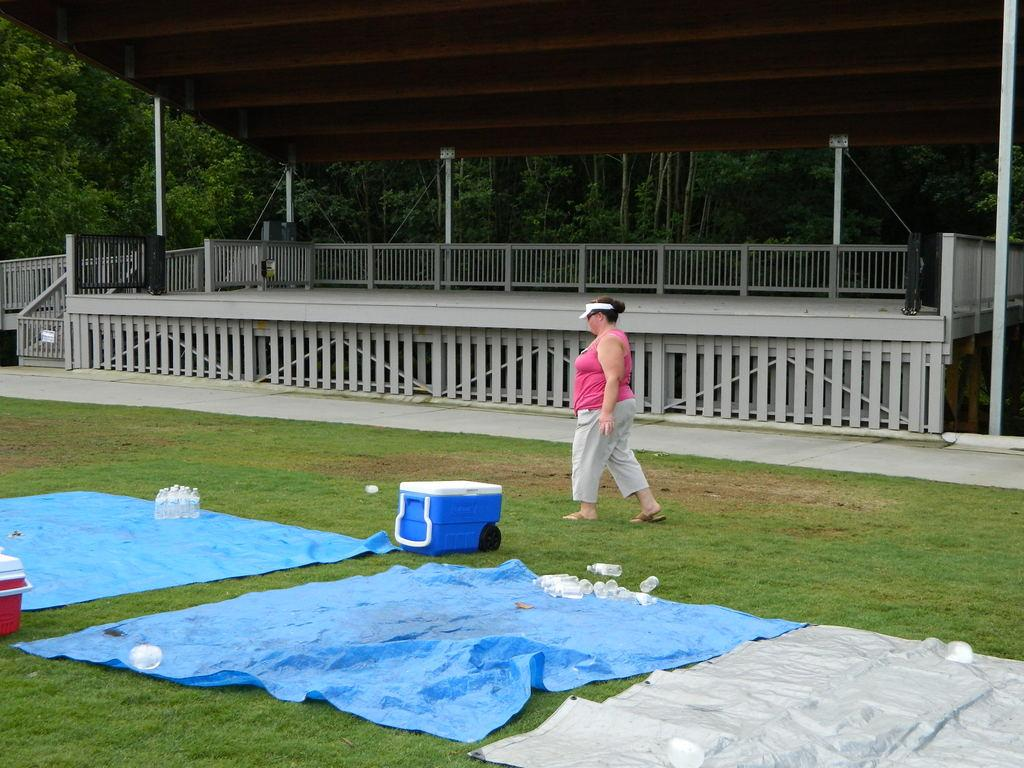What is the person in the image doing? The person is walking in the image. What color is the t-shirt the person is wearing? The person is wearing a pink t-shirt. What type of pants is the person wearing? The person is wearing trousers. What type of flooring can be seen in the image? There are plastic mats in the image. What type of containers are visible in the image? There are plastic bottles in the image. What is located at the back of the image? There is fencing and trees at the back of the image. What color is the cloth used to cover the father in the image? There is no father or cloth present in the image. 